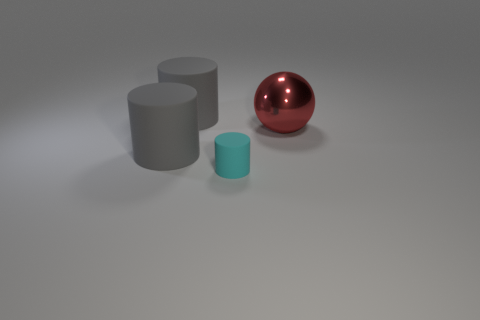Can you tell me the colors of the objects shown in the image? Certainly, the image displays three objects with distinct colors: a grey cylinder, a red sphere, and a cyan cylinder. 